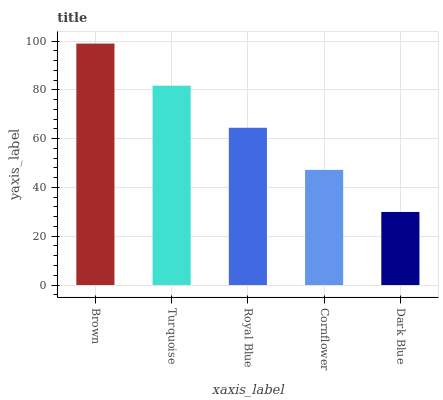Is Dark Blue the minimum?
Answer yes or no. Yes. Is Brown the maximum?
Answer yes or no. Yes. Is Turquoise the minimum?
Answer yes or no. No. Is Turquoise the maximum?
Answer yes or no. No. Is Brown greater than Turquoise?
Answer yes or no. Yes. Is Turquoise less than Brown?
Answer yes or no. Yes. Is Turquoise greater than Brown?
Answer yes or no. No. Is Brown less than Turquoise?
Answer yes or no. No. Is Royal Blue the high median?
Answer yes or no. Yes. Is Royal Blue the low median?
Answer yes or no. Yes. Is Turquoise the high median?
Answer yes or no. No. Is Brown the low median?
Answer yes or no. No. 